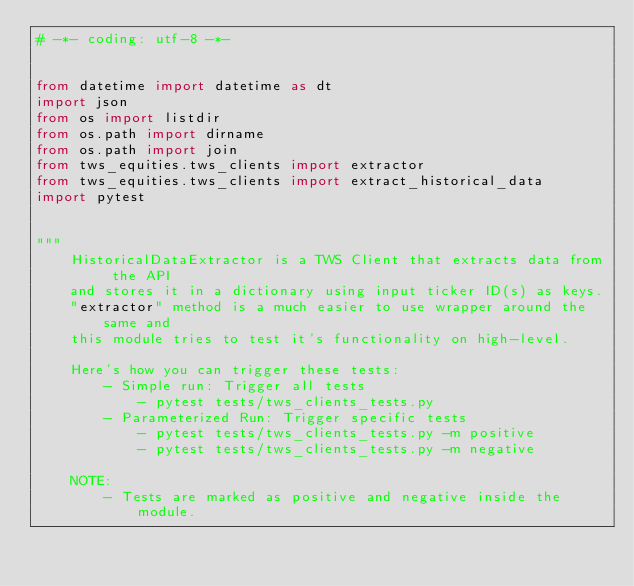<code> <loc_0><loc_0><loc_500><loc_500><_Python_># -*- coding: utf-8 -*-


from datetime import datetime as dt
import json
from os import listdir
from os.path import dirname
from os.path import join
from tws_equities.tws_clients import extractor
from tws_equities.tws_clients import extract_historical_data
import pytest


"""
    HistoricalDataExtractor is a TWS Client that extracts data from the API
    and stores it in a dictionary using input ticker ID(s) as keys.
    "extractor" method is a much easier to use wrapper around the same and
    this module tries to test it's functionality on high-level.

    Here's how you can trigger these tests:
        - Simple run: Trigger all tests
            - pytest tests/tws_clients_tests.py
        - Parameterized Run: Trigger specific tests
            - pytest tests/tws_clients_tests.py -m positive
            - pytest tests/tws_clients_tests.py -m negative

    NOTE:
        - Tests are marked as positive and negative inside the module.</code> 